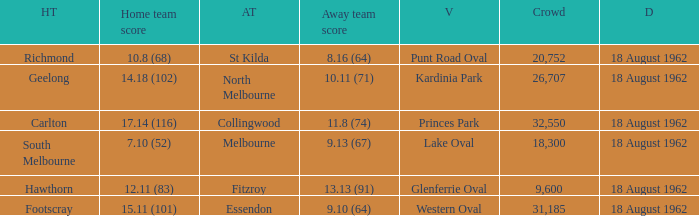At what venue where the home team scored 12.11 (83) was the crowd larger than 31,185? None. 